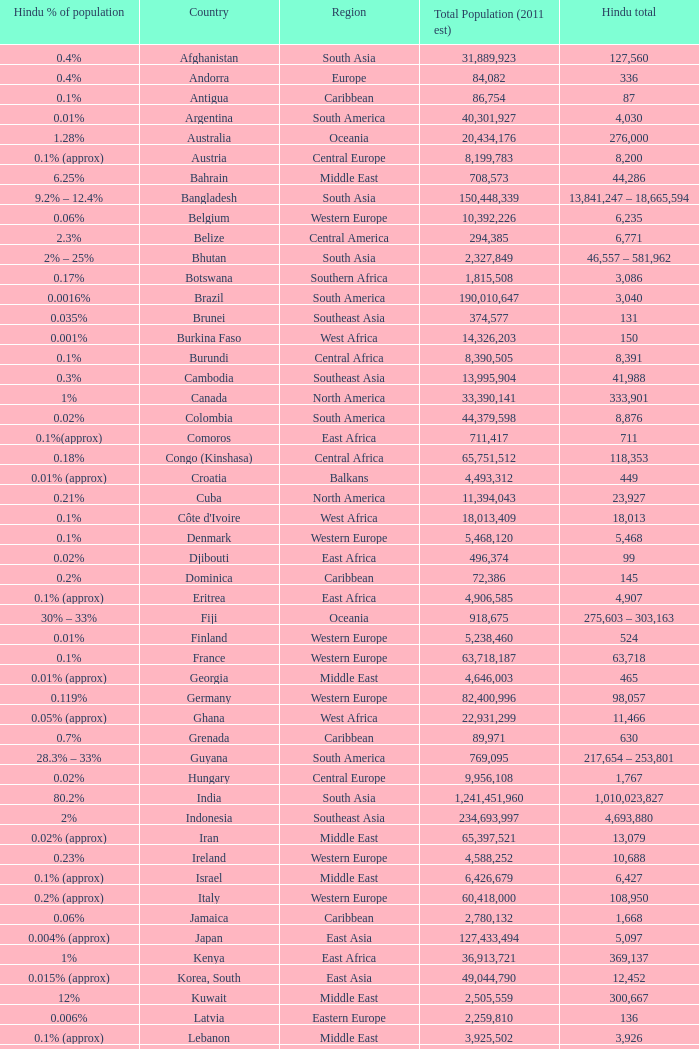Total Population (2011 est) larger than 30,262,610, and a Hindu total of 63,718 involves what country? France. 